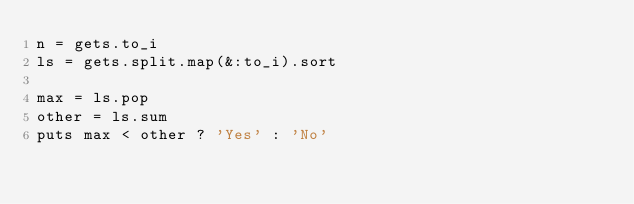<code> <loc_0><loc_0><loc_500><loc_500><_Ruby_>n = gets.to_i
ls = gets.split.map(&:to_i).sort

max = ls.pop
other = ls.sum
puts max < other ? 'Yes' : 'No'
</code> 